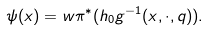<formula> <loc_0><loc_0><loc_500><loc_500>\psi ( x ) = w \pi ^ { * } ( h _ { 0 } g ^ { - 1 } ( x , \cdot , q ) ) .</formula> 